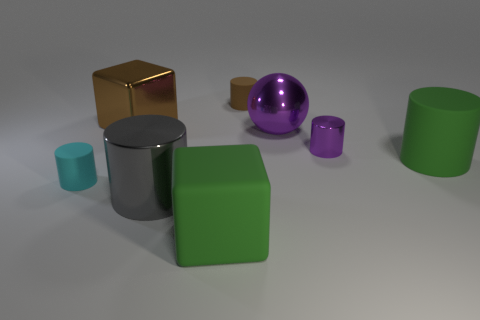How many things are either large green cylinders or rubber objects in front of the tiny brown rubber thing?
Make the answer very short. 3. Is the size of the matte cylinder in front of the big green rubber cylinder the same as the block behind the large green cylinder?
Ensure brevity in your answer.  No. Is there another big green cylinder made of the same material as the green cylinder?
Keep it short and to the point. No. There is a small cyan rubber thing; what shape is it?
Provide a short and direct response. Cylinder. There is a green matte object behind the large cube that is in front of the cyan object; what is its shape?
Ensure brevity in your answer.  Cylinder. What number of other objects are there of the same shape as the brown matte object?
Your answer should be compact. 4. How big is the metallic cylinder behind the tiny matte object that is in front of the purple cylinder?
Your response must be concise. Small. Are any red objects visible?
Your response must be concise. No. There is a big green matte object that is behind the big rubber block; what number of rubber objects are in front of it?
Provide a succinct answer. 2. There is a small rubber object left of the large brown thing; what shape is it?
Provide a succinct answer. Cylinder. 